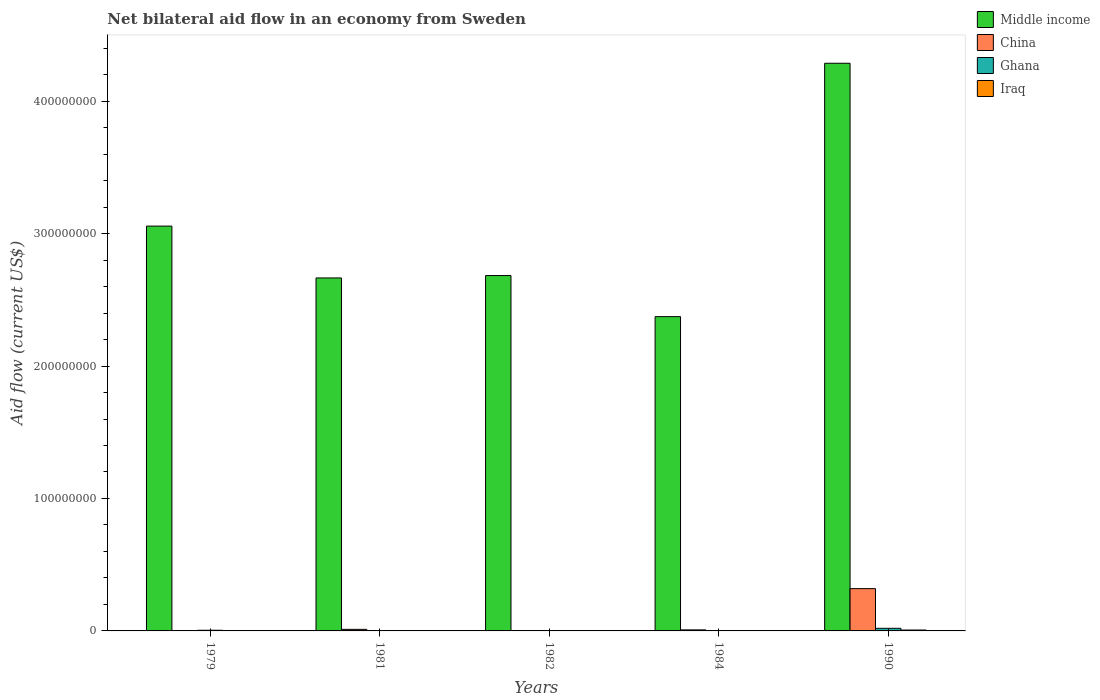How many bars are there on the 3rd tick from the right?
Offer a very short reply. 4. In how many cases, is the number of bars for a given year not equal to the number of legend labels?
Your answer should be very brief. 0. What is the net bilateral aid flow in Middle income in 1982?
Offer a very short reply. 2.68e+08. Across all years, what is the maximum net bilateral aid flow in Middle income?
Give a very brief answer. 4.29e+08. Across all years, what is the minimum net bilateral aid flow in China?
Your answer should be very brief. 9.00e+04. In which year was the net bilateral aid flow in Ghana maximum?
Your answer should be very brief. 1990. What is the total net bilateral aid flow in Iraq in the graph?
Give a very brief answer. 9.30e+05. What is the difference between the net bilateral aid flow in China in 1981 and that in 1982?
Make the answer very short. 9.30e+05. What is the difference between the net bilateral aid flow in China in 1982 and the net bilateral aid flow in Ghana in 1979?
Your response must be concise. -2.50e+05. What is the average net bilateral aid flow in Ghana per year?
Make the answer very short. 5.64e+05. In the year 1981, what is the difference between the net bilateral aid flow in China and net bilateral aid flow in Ghana?
Your response must be concise. 9.60e+05. In how many years, is the net bilateral aid flow in Middle income greater than 160000000 US$?
Your response must be concise. 5. What is the difference between the highest and the second highest net bilateral aid flow in Middle income?
Your answer should be compact. 1.23e+08. Is the sum of the net bilateral aid flow in Middle income in 1981 and 1984 greater than the maximum net bilateral aid flow in Ghana across all years?
Keep it short and to the point. Yes. What does the 2nd bar from the left in 1990 represents?
Provide a short and direct response. China. What does the 3rd bar from the right in 1982 represents?
Your response must be concise. China. How many bars are there?
Give a very brief answer. 20. Does the graph contain grids?
Give a very brief answer. No. Where does the legend appear in the graph?
Ensure brevity in your answer.  Top right. How many legend labels are there?
Offer a very short reply. 4. How are the legend labels stacked?
Your answer should be very brief. Vertical. What is the title of the graph?
Keep it short and to the point. Net bilateral aid flow in an economy from Sweden. Does "Vanuatu" appear as one of the legend labels in the graph?
Keep it short and to the point. No. What is the Aid flow (current US$) in Middle income in 1979?
Make the answer very short. 3.06e+08. What is the Aid flow (current US$) of China in 1979?
Offer a very short reply. 9.00e+04. What is the Aid flow (current US$) of Ghana in 1979?
Your response must be concise. 5.00e+05. What is the Aid flow (current US$) of Middle income in 1981?
Provide a short and direct response. 2.67e+08. What is the Aid flow (current US$) of China in 1981?
Ensure brevity in your answer.  1.18e+06. What is the Aid flow (current US$) of Middle income in 1982?
Offer a terse response. 2.68e+08. What is the Aid flow (current US$) of Iraq in 1982?
Your answer should be very brief. 6.00e+04. What is the Aid flow (current US$) in Middle income in 1984?
Your answer should be very brief. 2.37e+08. What is the Aid flow (current US$) of China in 1984?
Ensure brevity in your answer.  7.90e+05. What is the Aid flow (current US$) of Middle income in 1990?
Offer a very short reply. 4.29e+08. What is the Aid flow (current US$) of China in 1990?
Your response must be concise. 3.19e+07. What is the Aid flow (current US$) of Ghana in 1990?
Your answer should be very brief. 1.98e+06. What is the Aid flow (current US$) in Iraq in 1990?
Offer a terse response. 6.80e+05. Across all years, what is the maximum Aid flow (current US$) of Middle income?
Offer a terse response. 4.29e+08. Across all years, what is the maximum Aid flow (current US$) of China?
Offer a very short reply. 3.19e+07. Across all years, what is the maximum Aid flow (current US$) of Ghana?
Make the answer very short. 1.98e+06. Across all years, what is the maximum Aid flow (current US$) in Iraq?
Ensure brevity in your answer.  6.80e+05. Across all years, what is the minimum Aid flow (current US$) of Middle income?
Keep it short and to the point. 2.37e+08. Across all years, what is the minimum Aid flow (current US$) in China?
Offer a terse response. 9.00e+04. Across all years, what is the minimum Aid flow (current US$) of Iraq?
Keep it short and to the point. 2.00e+04. What is the total Aid flow (current US$) in Middle income in the graph?
Offer a terse response. 1.51e+09. What is the total Aid flow (current US$) of China in the graph?
Keep it short and to the point. 3.42e+07. What is the total Aid flow (current US$) of Ghana in the graph?
Give a very brief answer. 2.82e+06. What is the total Aid flow (current US$) of Iraq in the graph?
Offer a terse response. 9.30e+05. What is the difference between the Aid flow (current US$) in Middle income in 1979 and that in 1981?
Your answer should be compact. 3.92e+07. What is the difference between the Aid flow (current US$) of China in 1979 and that in 1981?
Your answer should be very brief. -1.09e+06. What is the difference between the Aid flow (current US$) in Ghana in 1979 and that in 1981?
Provide a succinct answer. 2.80e+05. What is the difference between the Aid flow (current US$) of Iraq in 1979 and that in 1981?
Ensure brevity in your answer.  10000. What is the difference between the Aid flow (current US$) of Middle income in 1979 and that in 1982?
Offer a terse response. 3.73e+07. What is the difference between the Aid flow (current US$) of China in 1979 and that in 1982?
Make the answer very short. -1.60e+05. What is the difference between the Aid flow (current US$) of Middle income in 1979 and that in 1984?
Your answer should be very brief. 6.84e+07. What is the difference between the Aid flow (current US$) in China in 1979 and that in 1984?
Give a very brief answer. -7.00e+05. What is the difference between the Aid flow (current US$) in Middle income in 1979 and that in 1990?
Offer a terse response. -1.23e+08. What is the difference between the Aid flow (current US$) of China in 1979 and that in 1990?
Your answer should be very brief. -3.18e+07. What is the difference between the Aid flow (current US$) in Ghana in 1979 and that in 1990?
Your answer should be very brief. -1.48e+06. What is the difference between the Aid flow (current US$) of Iraq in 1979 and that in 1990?
Give a very brief answer. -5.90e+05. What is the difference between the Aid flow (current US$) of Middle income in 1981 and that in 1982?
Provide a short and direct response. -1.81e+06. What is the difference between the Aid flow (current US$) in China in 1981 and that in 1982?
Keep it short and to the point. 9.30e+05. What is the difference between the Aid flow (current US$) of Middle income in 1981 and that in 1984?
Offer a very short reply. 2.92e+07. What is the difference between the Aid flow (current US$) in Ghana in 1981 and that in 1984?
Your response must be concise. 2.10e+05. What is the difference between the Aid flow (current US$) of Middle income in 1981 and that in 1990?
Your answer should be very brief. -1.62e+08. What is the difference between the Aid flow (current US$) in China in 1981 and that in 1990?
Provide a short and direct response. -3.08e+07. What is the difference between the Aid flow (current US$) in Ghana in 1981 and that in 1990?
Your response must be concise. -1.76e+06. What is the difference between the Aid flow (current US$) of Iraq in 1981 and that in 1990?
Provide a succinct answer. -6.00e+05. What is the difference between the Aid flow (current US$) in Middle income in 1982 and that in 1984?
Make the answer very short. 3.10e+07. What is the difference between the Aid flow (current US$) of China in 1982 and that in 1984?
Give a very brief answer. -5.40e+05. What is the difference between the Aid flow (current US$) of Middle income in 1982 and that in 1990?
Keep it short and to the point. -1.60e+08. What is the difference between the Aid flow (current US$) of China in 1982 and that in 1990?
Provide a succinct answer. -3.17e+07. What is the difference between the Aid flow (current US$) of Ghana in 1982 and that in 1990?
Offer a terse response. -1.87e+06. What is the difference between the Aid flow (current US$) in Iraq in 1982 and that in 1990?
Provide a succinct answer. -6.20e+05. What is the difference between the Aid flow (current US$) in Middle income in 1984 and that in 1990?
Your answer should be compact. -1.91e+08. What is the difference between the Aid flow (current US$) in China in 1984 and that in 1990?
Provide a short and direct response. -3.11e+07. What is the difference between the Aid flow (current US$) in Ghana in 1984 and that in 1990?
Your answer should be compact. -1.97e+06. What is the difference between the Aid flow (current US$) in Iraq in 1984 and that in 1990?
Offer a very short reply. -6.60e+05. What is the difference between the Aid flow (current US$) in Middle income in 1979 and the Aid flow (current US$) in China in 1981?
Your response must be concise. 3.04e+08. What is the difference between the Aid flow (current US$) of Middle income in 1979 and the Aid flow (current US$) of Ghana in 1981?
Make the answer very short. 3.05e+08. What is the difference between the Aid flow (current US$) of Middle income in 1979 and the Aid flow (current US$) of Iraq in 1981?
Keep it short and to the point. 3.06e+08. What is the difference between the Aid flow (current US$) in China in 1979 and the Aid flow (current US$) in Ghana in 1981?
Your answer should be compact. -1.30e+05. What is the difference between the Aid flow (current US$) in China in 1979 and the Aid flow (current US$) in Iraq in 1981?
Ensure brevity in your answer.  10000. What is the difference between the Aid flow (current US$) in Middle income in 1979 and the Aid flow (current US$) in China in 1982?
Offer a terse response. 3.05e+08. What is the difference between the Aid flow (current US$) in Middle income in 1979 and the Aid flow (current US$) in Ghana in 1982?
Ensure brevity in your answer.  3.06e+08. What is the difference between the Aid flow (current US$) of Middle income in 1979 and the Aid flow (current US$) of Iraq in 1982?
Keep it short and to the point. 3.06e+08. What is the difference between the Aid flow (current US$) of Middle income in 1979 and the Aid flow (current US$) of China in 1984?
Keep it short and to the point. 3.05e+08. What is the difference between the Aid flow (current US$) in Middle income in 1979 and the Aid flow (current US$) in Ghana in 1984?
Your answer should be very brief. 3.06e+08. What is the difference between the Aid flow (current US$) in Middle income in 1979 and the Aid flow (current US$) in Iraq in 1984?
Keep it short and to the point. 3.06e+08. What is the difference between the Aid flow (current US$) of China in 1979 and the Aid flow (current US$) of Ghana in 1984?
Keep it short and to the point. 8.00e+04. What is the difference between the Aid flow (current US$) in Ghana in 1979 and the Aid flow (current US$) in Iraq in 1984?
Offer a terse response. 4.80e+05. What is the difference between the Aid flow (current US$) in Middle income in 1979 and the Aid flow (current US$) in China in 1990?
Provide a short and direct response. 2.74e+08. What is the difference between the Aid flow (current US$) of Middle income in 1979 and the Aid flow (current US$) of Ghana in 1990?
Your answer should be very brief. 3.04e+08. What is the difference between the Aid flow (current US$) of Middle income in 1979 and the Aid flow (current US$) of Iraq in 1990?
Offer a very short reply. 3.05e+08. What is the difference between the Aid flow (current US$) in China in 1979 and the Aid flow (current US$) in Ghana in 1990?
Your answer should be very brief. -1.89e+06. What is the difference between the Aid flow (current US$) in China in 1979 and the Aid flow (current US$) in Iraq in 1990?
Provide a succinct answer. -5.90e+05. What is the difference between the Aid flow (current US$) of Middle income in 1981 and the Aid flow (current US$) of China in 1982?
Your answer should be very brief. 2.66e+08. What is the difference between the Aid flow (current US$) in Middle income in 1981 and the Aid flow (current US$) in Ghana in 1982?
Provide a succinct answer. 2.66e+08. What is the difference between the Aid flow (current US$) in Middle income in 1981 and the Aid flow (current US$) in Iraq in 1982?
Your answer should be very brief. 2.66e+08. What is the difference between the Aid flow (current US$) in China in 1981 and the Aid flow (current US$) in Ghana in 1982?
Make the answer very short. 1.07e+06. What is the difference between the Aid flow (current US$) in China in 1981 and the Aid flow (current US$) in Iraq in 1982?
Offer a very short reply. 1.12e+06. What is the difference between the Aid flow (current US$) in Ghana in 1981 and the Aid flow (current US$) in Iraq in 1982?
Keep it short and to the point. 1.60e+05. What is the difference between the Aid flow (current US$) in Middle income in 1981 and the Aid flow (current US$) in China in 1984?
Keep it short and to the point. 2.66e+08. What is the difference between the Aid flow (current US$) in Middle income in 1981 and the Aid flow (current US$) in Ghana in 1984?
Offer a terse response. 2.67e+08. What is the difference between the Aid flow (current US$) of Middle income in 1981 and the Aid flow (current US$) of Iraq in 1984?
Your answer should be very brief. 2.66e+08. What is the difference between the Aid flow (current US$) of China in 1981 and the Aid flow (current US$) of Ghana in 1984?
Ensure brevity in your answer.  1.17e+06. What is the difference between the Aid flow (current US$) in China in 1981 and the Aid flow (current US$) in Iraq in 1984?
Your answer should be compact. 1.16e+06. What is the difference between the Aid flow (current US$) of Middle income in 1981 and the Aid flow (current US$) of China in 1990?
Offer a very short reply. 2.35e+08. What is the difference between the Aid flow (current US$) of Middle income in 1981 and the Aid flow (current US$) of Ghana in 1990?
Keep it short and to the point. 2.65e+08. What is the difference between the Aid flow (current US$) in Middle income in 1981 and the Aid flow (current US$) in Iraq in 1990?
Your response must be concise. 2.66e+08. What is the difference between the Aid flow (current US$) in China in 1981 and the Aid flow (current US$) in Ghana in 1990?
Your response must be concise. -8.00e+05. What is the difference between the Aid flow (current US$) in Ghana in 1981 and the Aid flow (current US$) in Iraq in 1990?
Provide a short and direct response. -4.60e+05. What is the difference between the Aid flow (current US$) of Middle income in 1982 and the Aid flow (current US$) of China in 1984?
Keep it short and to the point. 2.68e+08. What is the difference between the Aid flow (current US$) in Middle income in 1982 and the Aid flow (current US$) in Ghana in 1984?
Your answer should be compact. 2.68e+08. What is the difference between the Aid flow (current US$) of Middle income in 1982 and the Aid flow (current US$) of Iraq in 1984?
Ensure brevity in your answer.  2.68e+08. What is the difference between the Aid flow (current US$) in Ghana in 1982 and the Aid flow (current US$) in Iraq in 1984?
Offer a terse response. 9.00e+04. What is the difference between the Aid flow (current US$) in Middle income in 1982 and the Aid flow (current US$) in China in 1990?
Your response must be concise. 2.36e+08. What is the difference between the Aid flow (current US$) in Middle income in 1982 and the Aid flow (current US$) in Ghana in 1990?
Your response must be concise. 2.66e+08. What is the difference between the Aid flow (current US$) of Middle income in 1982 and the Aid flow (current US$) of Iraq in 1990?
Give a very brief answer. 2.68e+08. What is the difference between the Aid flow (current US$) of China in 1982 and the Aid flow (current US$) of Ghana in 1990?
Give a very brief answer. -1.73e+06. What is the difference between the Aid flow (current US$) of China in 1982 and the Aid flow (current US$) of Iraq in 1990?
Make the answer very short. -4.30e+05. What is the difference between the Aid flow (current US$) in Ghana in 1982 and the Aid flow (current US$) in Iraq in 1990?
Make the answer very short. -5.70e+05. What is the difference between the Aid flow (current US$) in Middle income in 1984 and the Aid flow (current US$) in China in 1990?
Your answer should be compact. 2.05e+08. What is the difference between the Aid flow (current US$) in Middle income in 1984 and the Aid flow (current US$) in Ghana in 1990?
Offer a terse response. 2.35e+08. What is the difference between the Aid flow (current US$) of Middle income in 1984 and the Aid flow (current US$) of Iraq in 1990?
Provide a succinct answer. 2.37e+08. What is the difference between the Aid flow (current US$) in China in 1984 and the Aid flow (current US$) in Ghana in 1990?
Keep it short and to the point. -1.19e+06. What is the difference between the Aid flow (current US$) of Ghana in 1984 and the Aid flow (current US$) of Iraq in 1990?
Provide a succinct answer. -6.70e+05. What is the average Aid flow (current US$) of Middle income per year?
Provide a succinct answer. 3.01e+08. What is the average Aid flow (current US$) of China per year?
Provide a succinct answer. 6.85e+06. What is the average Aid flow (current US$) of Ghana per year?
Offer a very short reply. 5.64e+05. What is the average Aid flow (current US$) of Iraq per year?
Make the answer very short. 1.86e+05. In the year 1979, what is the difference between the Aid flow (current US$) of Middle income and Aid flow (current US$) of China?
Ensure brevity in your answer.  3.06e+08. In the year 1979, what is the difference between the Aid flow (current US$) in Middle income and Aid flow (current US$) in Ghana?
Keep it short and to the point. 3.05e+08. In the year 1979, what is the difference between the Aid flow (current US$) of Middle income and Aid flow (current US$) of Iraq?
Give a very brief answer. 3.06e+08. In the year 1979, what is the difference between the Aid flow (current US$) of China and Aid flow (current US$) of Ghana?
Offer a terse response. -4.10e+05. In the year 1979, what is the difference between the Aid flow (current US$) of China and Aid flow (current US$) of Iraq?
Provide a succinct answer. 0. In the year 1981, what is the difference between the Aid flow (current US$) of Middle income and Aid flow (current US$) of China?
Offer a very short reply. 2.65e+08. In the year 1981, what is the difference between the Aid flow (current US$) in Middle income and Aid flow (current US$) in Ghana?
Your answer should be compact. 2.66e+08. In the year 1981, what is the difference between the Aid flow (current US$) in Middle income and Aid flow (current US$) in Iraq?
Ensure brevity in your answer.  2.66e+08. In the year 1981, what is the difference between the Aid flow (current US$) in China and Aid flow (current US$) in Ghana?
Your answer should be compact. 9.60e+05. In the year 1981, what is the difference between the Aid flow (current US$) of China and Aid flow (current US$) of Iraq?
Make the answer very short. 1.10e+06. In the year 1981, what is the difference between the Aid flow (current US$) in Ghana and Aid flow (current US$) in Iraq?
Your answer should be compact. 1.40e+05. In the year 1982, what is the difference between the Aid flow (current US$) of Middle income and Aid flow (current US$) of China?
Make the answer very short. 2.68e+08. In the year 1982, what is the difference between the Aid flow (current US$) in Middle income and Aid flow (current US$) in Ghana?
Keep it short and to the point. 2.68e+08. In the year 1982, what is the difference between the Aid flow (current US$) in Middle income and Aid flow (current US$) in Iraq?
Offer a terse response. 2.68e+08. In the year 1982, what is the difference between the Aid flow (current US$) in China and Aid flow (current US$) in Iraq?
Ensure brevity in your answer.  1.90e+05. In the year 1982, what is the difference between the Aid flow (current US$) in Ghana and Aid flow (current US$) in Iraq?
Your answer should be very brief. 5.00e+04. In the year 1984, what is the difference between the Aid flow (current US$) of Middle income and Aid flow (current US$) of China?
Keep it short and to the point. 2.37e+08. In the year 1984, what is the difference between the Aid flow (current US$) in Middle income and Aid flow (current US$) in Ghana?
Ensure brevity in your answer.  2.37e+08. In the year 1984, what is the difference between the Aid flow (current US$) in Middle income and Aid flow (current US$) in Iraq?
Your answer should be very brief. 2.37e+08. In the year 1984, what is the difference between the Aid flow (current US$) of China and Aid flow (current US$) of Ghana?
Your answer should be very brief. 7.80e+05. In the year 1984, what is the difference between the Aid flow (current US$) in China and Aid flow (current US$) in Iraq?
Make the answer very short. 7.70e+05. In the year 1990, what is the difference between the Aid flow (current US$) of Middle income and Aid flow (current US$) of China?
Your answer should be very brief. 3.97e+08. In the year 1990, what is the difference between the Aid flow (current US$) in Middle income and Aid flow (current US$) in Ghana?
Keep it short and to the point. 4.27e+08. In the year 1990, what is the difference between the Aid flow (current US$) of Middle income and Aid flow (current US$) of Iraq?
Your response must be concise. 4.28e+08. In the year 1990, what is the difference between the Aid flow (current US$) of China and Aid flow (current US$) of Ghana?
Keep it short and to the point. 3.00e+07. In the year 1990, what is the difference between the Aid flow (current US$) of China and Aid flow (current US$) of Iraq?
Make the answer very short. 3.12e+07. In the year 1990, what is the difference between the Aid flow (current US$) in Ghana and Aid flow (current US$) in Iraq?
Offer a very short reply. 1.30e+06. What is the ratio of the Aid flow (current US$) in Middle income in 1979 to that in 1981?
Make the answer very short. 1.15. What is the ratio of the Aid flow (current US$) in China in 1979 to that in 1981?
Provide a short and direct response. 0.08. What is the ratio of the Aid flow (current US$) in Ghana in 1979 to that in 1981?
Offer a terse response. 2.27. What is the ratio of the Aid flow (current US$) in Middle income in 1979 to that in 1982?
Your response must be concise. 1.14. What is the ratio of the Aid flow (current US$) in China in 1979 to that in 1982?
Ensure brevity in your answer.  0.36. What is the ratio of the Aid flow (current US$) in Ghana in 1979 to that in 1982?
Offer a terse response. 4.55. What is the ratio of the Aid flow (current US$) of Middle income in 1979 to that in 1984?
Your answer should be compact. 1.29. What is the ratio of the Aid flow (current US$) in China in 1979 to that in 1984?
Keep it short and to the point. 0.11. What is the ratio of the Aid flow (current US$) of Middle income in 1979 to that in 1990?
Your answer should be compact. 0.71. What is the ratio of the Aid flow (current US$) of China in 1979 to that in 1990?
Your response must be concise. 0. What is the ratio of the Aid flow (current US$) of Ghana in 1979 to that in 1990?
Give a very brief answer. 0.25. What is the ratio of the Aid flow (current US$) in Iraq in 1979 to that in 1990?
Offer a terse response. 0.13. What is the ratio of the Aid flow (current US$) of China in 1981 to that in 1982?
Offer a very short reply. 4.72. What is the ratio of the Aid flow (current US$) of Ghana in 1981 to that in 1982?
Offer a terse response. 2. What is the ratio of the Aid flow (current US$) in Iraq in 1981 to that in 1982?
Your answer should be compact. 1.33. What is the ratio of the Aid flow (current US$) of Middle income in 1981 to that in 1984?
Provide a succinct answer. 1.12. What is the ratio of the Aid flow (current US$) of China in 1981 to that in 1984?
Provide a succinct answer. 1.49. What is the ratio of the Aid flow (current US$) of Middle income in 1981 to that in 1990?
Offer a terse response. 0.62. What is the ratio of the Aid flow (current US$) in China in 1981 to that in 1990?
Provide a short and direct response. 0.04. What is the ratio of the Aid flow (current US$) in Ghana in 1981 to that in 1990?
Ensure brevity in your answer.  0.11. What is the ratio of the Aid flow (current US$) of Iraq in 1981 to that in 1990?
Provide a succinct answer. 0.12. What is the ratio of the Aid flow (current US$) in Middle income in 1982 to that in 1984?
Provide a succinct answer. 1.13. What is the ratio of the Aid flow (current US$) of China in 1982 to that in 1984?
Provide a succinct answer. 0.32. What is the ratio of the Aid flow (current US$) in Middle income in 1982 to that in 1990?
Make the answer very short. 0.63. What is the ratio of the Aid flow (current US$) in China in 1982 to that in 1990?
Ensure brevity in your answer.  0.01. What is the ratio of the Aid flow (current US$) in Ghana in 1982 to that in 1990?
Your answer should be very brief. 0.06. What is the ratio of the Aid flow (current US$) in Iraq in 1982 to that in 1990?
Your answer should be compact. 0.09. What is the ratio of the Aid flow (current US$) of Middle income in 1984 to that in 1990?
Your response must be concise. 0.55. What is the ratio of the Aid flow (current US$) in China in 1984 to that in 1990?
Make the answer very short. 0.02. What is the ratio of the Aid flow (current US$) of Ghana in 1984 to that in 1990?
Provide a succinct answer. 0.01. What is the ratio of the Aid flow (current US$) in Iraq in 1984 to that in 1990?
Keep it short and to the point. 0.03. What is the difference between the highest and the second highest Aid flow (current US$) in Middle income?
Keep it short and to the point. 1.23e+08. What is the difference between the highest and the second highest Aid flow (current US$) in China?
Your response must be concise. 3.08e+07. What is the difference between the highest and the second highest Aid flow (current US$) of Ghana?
Provide a short and direct response. 1.48e+06. What is the difference between the highest and the second highest Aid flow (current US$) in Iraq?
Your answer should be compact. 5.90e+05. What is the difference between the highest and the lowest Aid flow (current US$) of Middle income?
Provide a short and direct response. 1.91e+08. What is the difference between the highest and the lowest Aid flow (current US$) of China?
Ensure brevity in your answer.  3.18e+07. What is the difference between the highest and the lowest Aid flow (current US$) of Ghana?
Keep it short and to the point. 1.97e+06. 